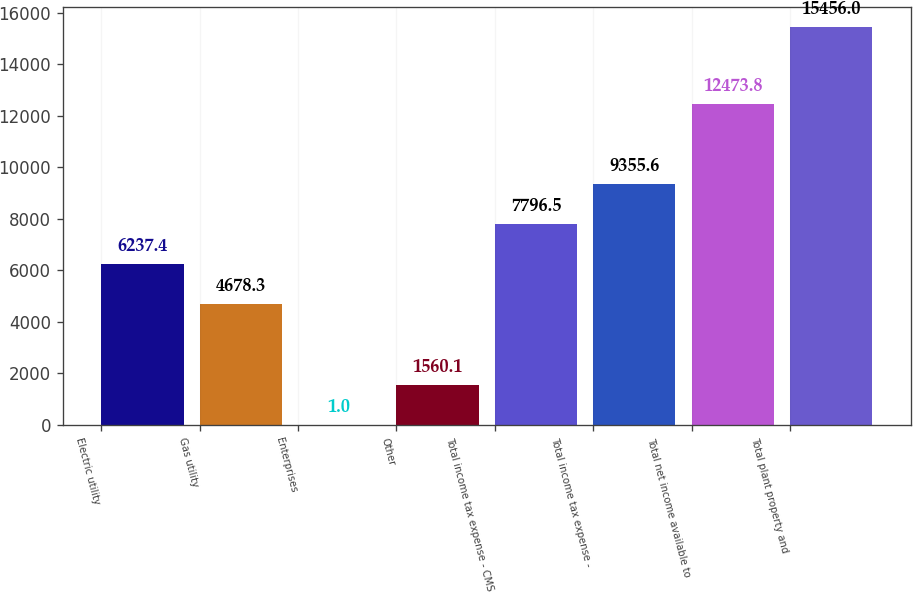Convert chart to OTSL. <chart><loc_0><loc_0><loc_500><loc_500><bar_chart><fcel>Electric utility<fcel>Gas utility<fcel>Enterprises<fcel>Other<fcel>Total income tax expense - CMS<fcel>Total income tax expense -<fcel>Total net income available to<fcel>Total plant property and<nl><fcel>6237.4<fcel>4678.3<fcel>1<fcel>1560.1<fcel>7796.5<fcel>9355.6<fcel>12473.8<fcel>15456<nl></chart> 